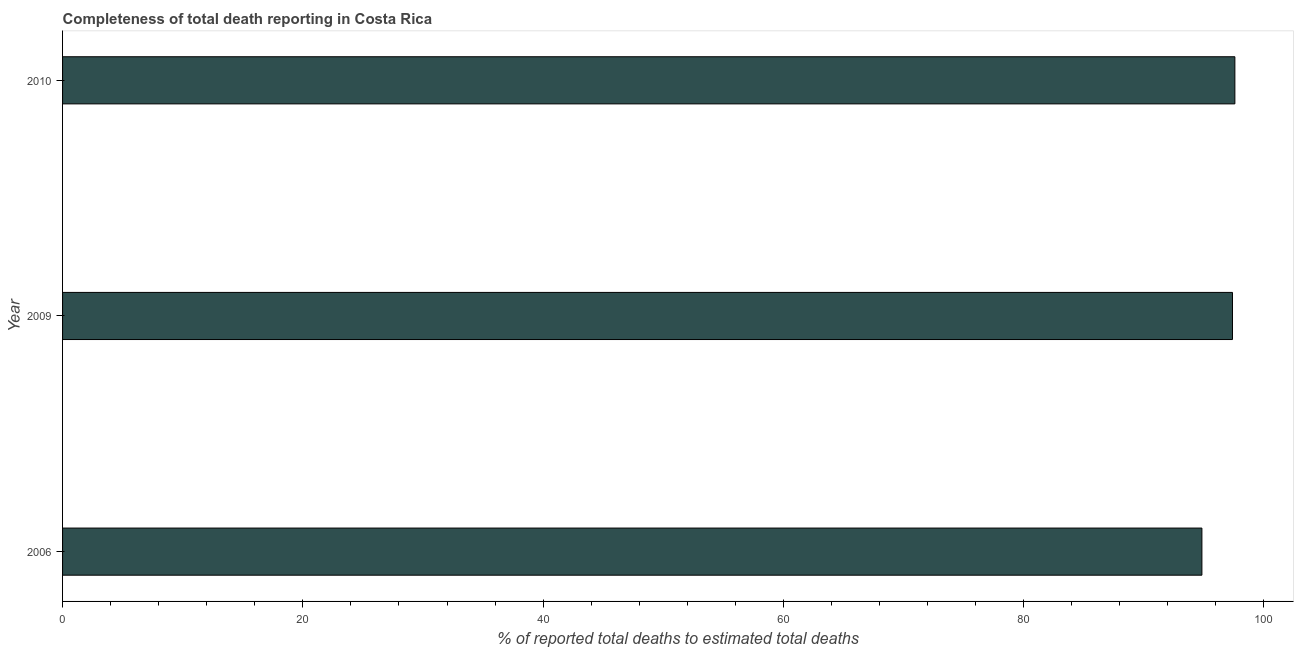Does the graph contain any zero values?
Provide a succinct answer. No. Does the graph contain grids?
Offer a terse response. No. What is the title of the graph?
Your answer should be compact. Completeness of total death reporting in Costa Rica. What is the label or title of the X-axis?
Provide a short and direct response. % of reported total deaths to estimated total deaths. What is the label or title of the Y-axis?
Your answer should be compact. Year. What is the completeness of total death reports in 2009?
Your answer should be very brief. 97.38. Across all years, what is the maximum completeness of total death reports?
Your answer should be very brief. 97.58. Across all years, what is the minimum completeness of total death reports?
Give a very brief answer. 94.84. In which year was the completeness of total death reports maximum?
Keep it short and to the point. 2010. In which year was the completeness of total death reports minimum?
Ensure brevity in your answer.  2006. What is the sum of the completeness of total death reports?
Your response must be concise. 289.8. What is the difference between the completeness of total death reports in 2009 and 2010?
Your answer should be very brief. -0.2. What is the average completeness of total death reports per year?
Offer a very short reply. 96.6. What is the median completeness of total death reports?
Keep it short and to the point. 97.38. Do a majority of the years between 2009 and 2006 (inclusive) have completeness of total death reports greater than 12 %?
Make the answer very short. No. What is the difference between the highest and the second highest completeness of total death reports?
Provide a short and direct response. 0.2. What is the difference between the highest and the lowest completeness of total death reports?
Provide a short and direct response. 2.74. How many bars are there?
Your answer should be very brief. 3. How many years are there in the graph?
Provide a succinct answer. 3. What is the difference between two consecutive major ticks on the X-axis?
Your answer should be compact. 20. What is the % of reported total deaths to estimated total deaths of 2006?
Provide a short and direct response. 94.84. What is the % of reported total deaths to estimated total deaths in 2009?
Provide a short and direct response. 97.38. What is the % of reported total deaths to estimated total deaths in 2010?
Provide a succinct answer. 97.58. What is the difference between the % of reported total deaths to estimated total deaths in 2006 and 2009?
Offer a very short reply. -2.55. What is the difference between the % of reported total deaths to estimated total deaths in 2006 and 2010?
Offer a very short reply. -2.74. What is the difference between the % of reported total deaths to estimated total deaths in 2009 and 2010?
Provide a short and direct response. -0.2. What is the ratio of the % of reported total deaths to estimated total deaths in 2009 to that in 2010?
Offer a very short reply. 1. 